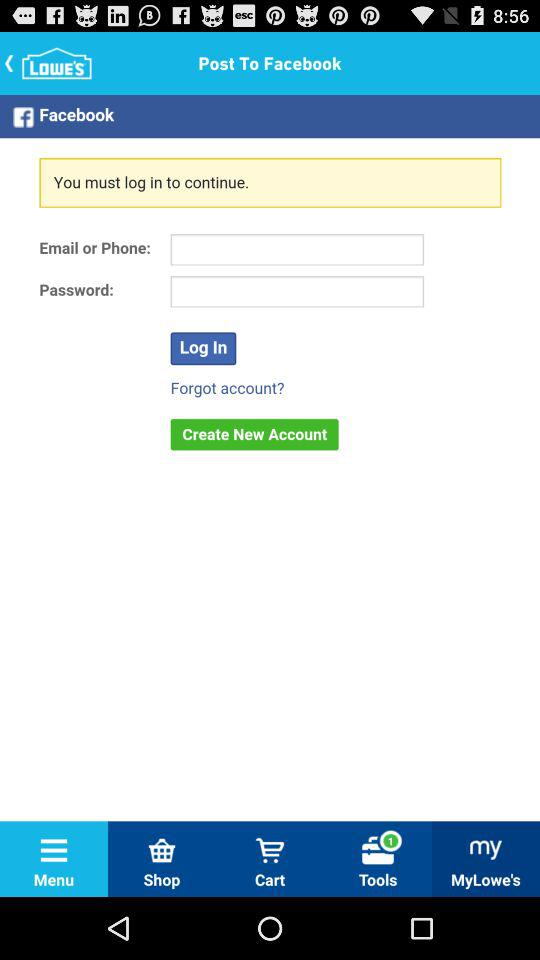Can we reset account?
When the provided information is insufficient, respond with <no answer>. <no answer> 